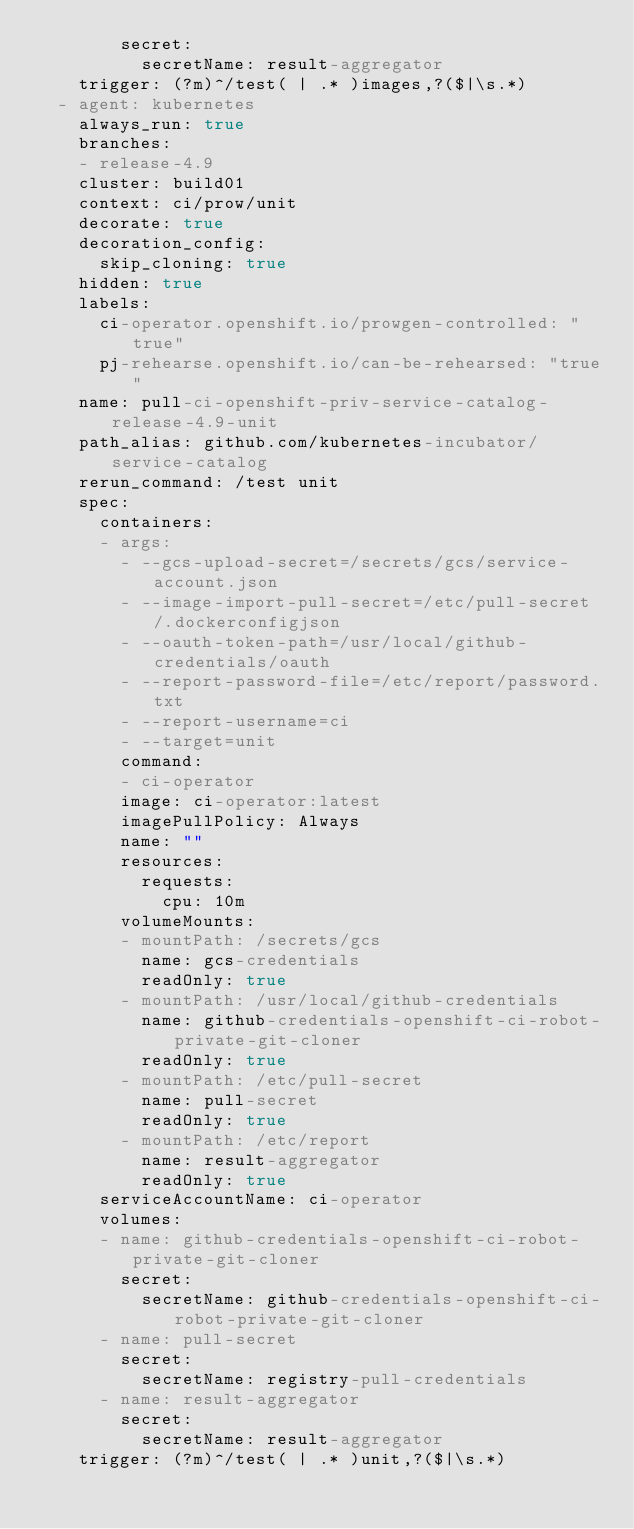Convert code to text. <code><loc_0><loc_0><loc_500><loc_500><_YAML_>        secret:
          secretName: result-aggregator
    trigger: (?m)^/test( | .* )images,?($|\s.*)
  - agent: kubernetes
    always_run: true
    branches:
    - release-4.9
    cluster: build01
    context: ci/prow/unit
    decorate: true
    decoration_config:
      skip_cloning: true
    hidden: true
    labels:
      ci-operator.openshift.io/prowgen-controlled: "true"
      pj-rehearse.openshift.io/can-be-rehearsed: "true"
    name: pull-ci-openshift-priv-service-catalog-release-4.9-unit
    path_alias: github.com/kubernetes-incubator/service-catalog
    rerun_command: /test unit
    spec:
      containers:
      - args:
        - --gcs-upload-secret=/secrets/gcs/service-account.json
        - --image-import-pull-secret=/etc/pull-secret/.dockerconfigjson
        - --oauth-token-path=/usr/local/github-credentials/oauth
        - --report-password-file=/etc/report/password.txt
        - --report-username=ci
        - --target=unit
        command:
        - ci-operator
        image: ci-operator:latest
        imagePullPolicy: Always
        name: ""
        resources:
          requests:
            cpu: 10m
        volumeMounts:
        - mountPath: /secrets/gcs
          name: gcs-credentials
          readOnly: true
        - mountPath: /usr/local/github-credentials
          name: github-credentials-openshift-ci-robot-private-git-cloner
          readOnly: true
        - mountPath: /etc/pull-secret
          name: pull-secret
          readOnly: true
        - mountPath: /etc/report
          name: result-aggregator
          readOnly: true
      serviceAccountName: ci-operator
      volumes:
      - name: github-credentials-openshift-ci-robot-private-git-cloner
        secret:
          secretName: github-credentials-openshift-ci-robot-private-git-cloner
      - name: pull-secret
        secret:
          secretName: registry-pull-credentials
      - name: result-aggregator
        secret:
          secretName: result-aggregator
    trigger: (?m)^/test( | .* )unit,?($|\s.*)
</code> 